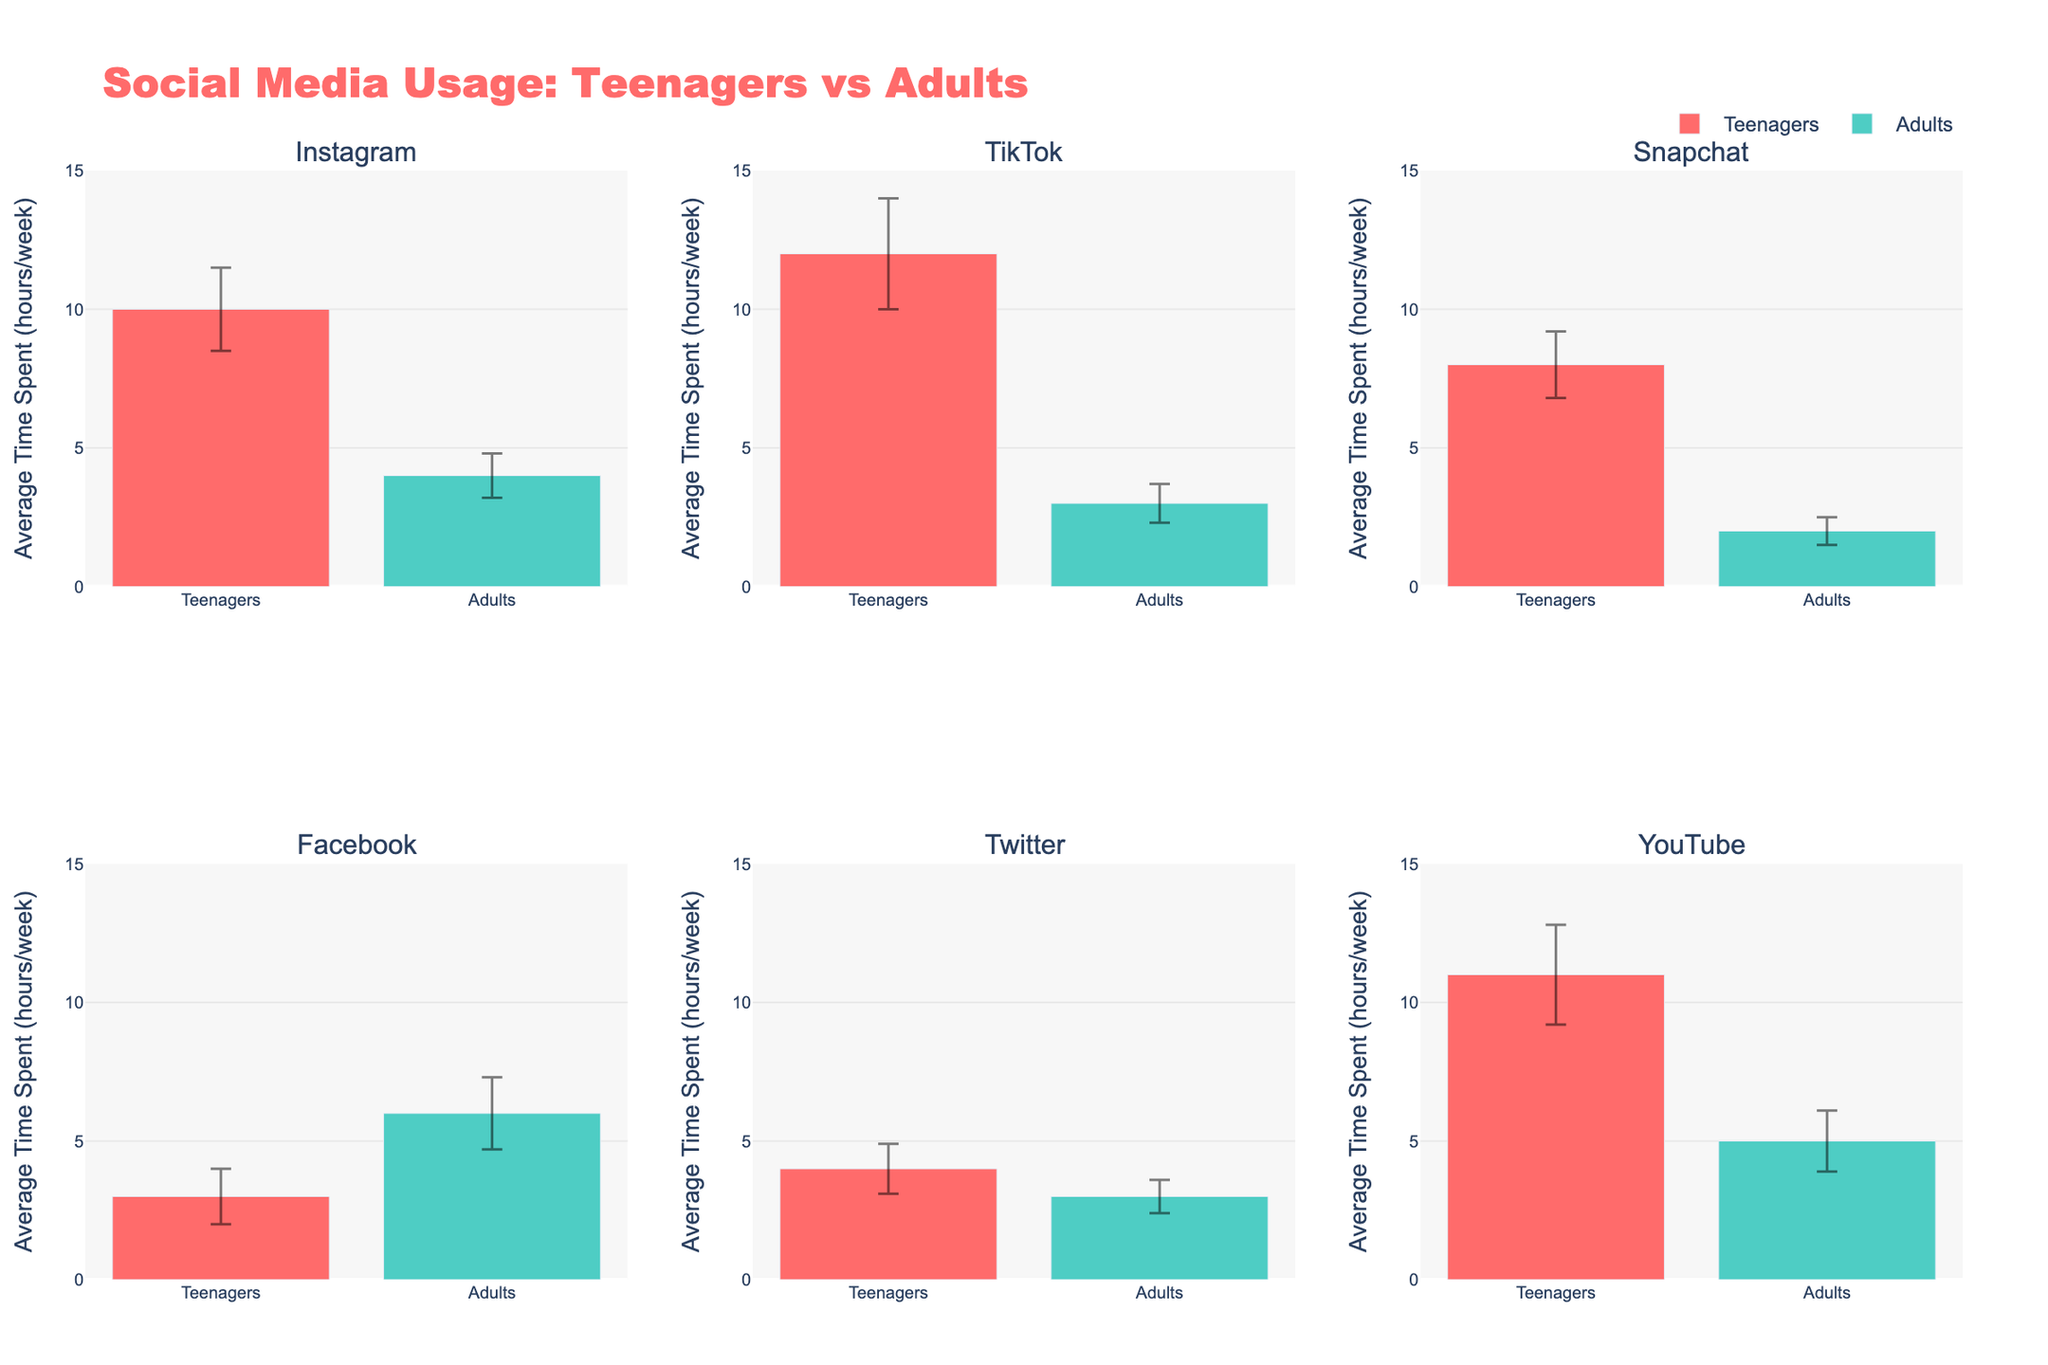Which platform do teenagers spend the most time on? From the figure, TikTok has the highest average time spent by teenagers, which is 12 hours per week, making it the platform with the most time spent.
Answer: TikTok What is the title of the figure? The title is located at the top of the figure. It reads "Social Media Usage: Teenagers vs Adults".
Answer: Social Media Usage: Teenagers vs Adults How many different social media platforms are compared in the figure? The figure has subplots for six different social media platforms: Instagram, TikTok, Snapchat, Facebook, Twitter, and YouTube.
Answer: Six Which age group spends more time on Facebook, teenagers or adults? From the Facebook subplot, adults spend more time (6 hours) compared to teenagers (3 hours).
Answer: Adults What is the standard deviation of average time spent by teenagers on YouTube? From the YouTube subplot, the standard deviation for teenagers is 1.8 hours.
Answer: 1.8 On which platform do adults have the smallest variation in usage? The platform with the smallest error bar for adults indicates the least variation. From the subplots, TikTok shows the smallest error bar of 0.7 hours for adults.
Answer: TikTok What is the total average weekly time spent by adults on Instagram and Snapchat combined? From the figure, adults spend on average 4 hours on Instagram and 2 hours on Snapchat. Summing these gives 4 + 2 = 6 hours.
Answer: 6 hours Which platform has the smallest difference in average usage between teenagers and adults? Comparing the differences for each platform: 
- Instagram: 10 - 4 = 6 hours
- TikTok: 12 - 3 = 9 hours
- Snapchat: 8 - 2 = 6 hours
- Facebook: 6 - 3 = 3 hours
- Twitter: 4 - 3 = 1 hour
- YouTube: 11 - 5 = 6 hours 
The smallest difference is 1 hour for Twitter.
Answer: Twitter Which age group shows the highest standard deviation in usage across any platform? By observing the error bars, teenagers on TikTok have the highest standard deviation of 2 hours which is the largest across all platforms and age groups.
Answer: Teenagers on TikTok 